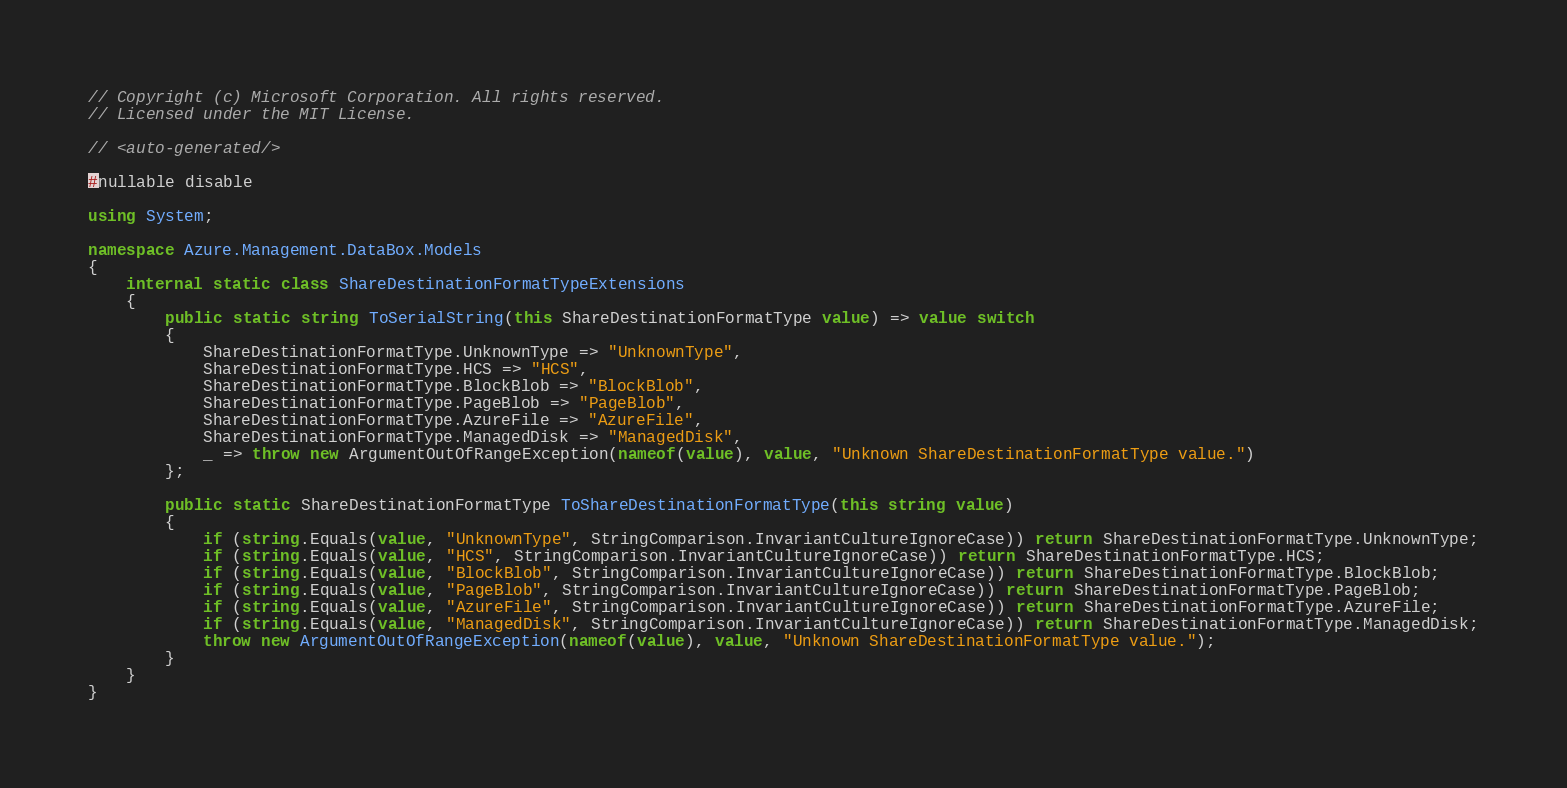<code> <loc_0><loc_0><loc_500><loc_500><_C#_>// Copyright (c) Microsoft Corporation. All rights reserved.
// Licensed under the MIT License.

// <auto-generated/>

#nullable disable

using System;

namespace Azure.Management.DataBox.Models
{
    internal static class ShareDestinationFormatTypeExtensions
    {
        public static string ToSerialString(this ShareDestinationFormatType value) => value switch
        {
            ShareDestinationFormatType.UnknownType => "UnknownType",
            ShareDestinationFormatType.HCS => "HCS",
            ShareDestinationFormatType.BlockBlob => "BlockBlob",
            ShareDestinationFormatType.PageBlob => "PageBlob",
            ShareDestinationFormatType.AzureFile => "AzureFile",
            ShareDestinationFormatType.ManagedDisk => "ManagedDisk",
            _ => throw new ArgumentOutOfRangeException(nameof(value), value, "Unknown ShareDestinationFormatType value.")
        };

        public static ShareDestinationFormatType ToShareDestinationFormatType(this string value)
        {
            if (string.Equals(value, "UnknownType", StringComparison.InvariantCultureIgnoreCase)) return ShareDestinationFormatType.UnknownType;
            if (string.Equals(value, "HCS", StringComparison.InvariantCultureIgnoreCase)) return ShareDestinationFormatType.HCS;
            if (string.Equals(value, "BlockBlob", StringComparison.InvariantCultureIgnoreCase)) return ShareDestinationFormatType.BlockBlob;
            if (string.Equals(value, "PageBlob", StringComparison.InvariantCultureIgnoreCase)) return ShareDestinationFormatType.PageBlob;
            if (string.Equals(value, "AzureFile", StringComparison.InvariantCultureIgnoreCase)) return ShareDestinationFormatType.AzureFile;
            if (string.Equals(value, "ManagedDisk", StringComparison.InvariantCultureIgnoreCase)) return ShareDestinationFormatType.ManagedDisk;
            throw new ArgumentOutOfRangeException(nameof(value), value, "Unknown ShareDestinationFormatType value.");
        }
    }
}
</code> 